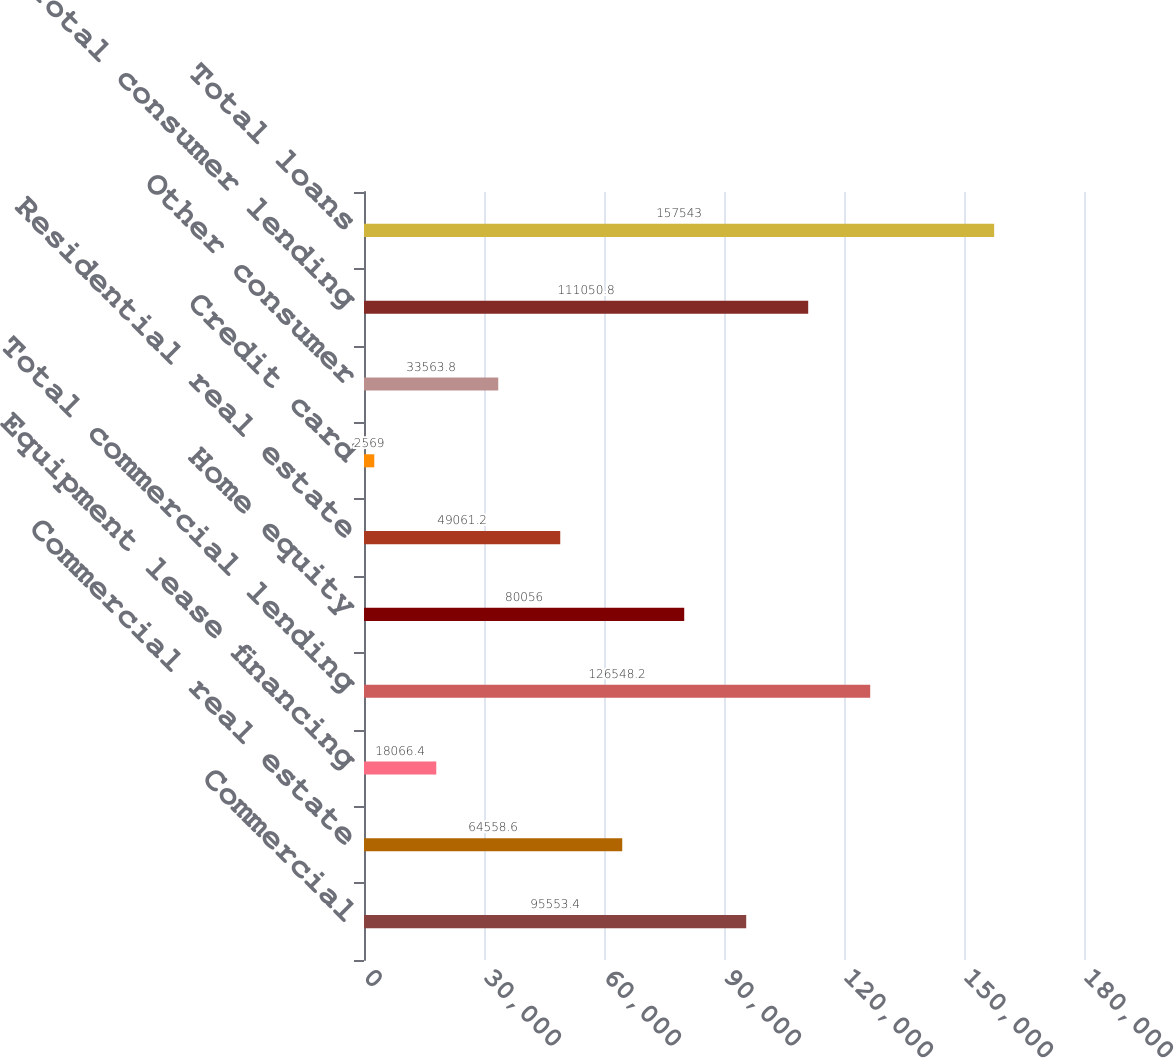<chart> <loc_0><loc_0><loc_500><loc_500><bar_chart><fcel>Commercial<fcel>Commercial real estate<fcel>Equipment lease financing<fcel>Total commercial lending<fcel>Home equity<fcel>Residential real estate<fcel>Credit card<fcel>Other consumer<fcel>Total consumer lending<fcel>Total loans<nl><fcel>95553.4<fcel>64558.6<fcel>18066.4<fcel>126548<fcel>80056<fcel>49061.2<fcel>2569<fcel>33563.8<fcel>111051<fcel>157543<nl></chart> 